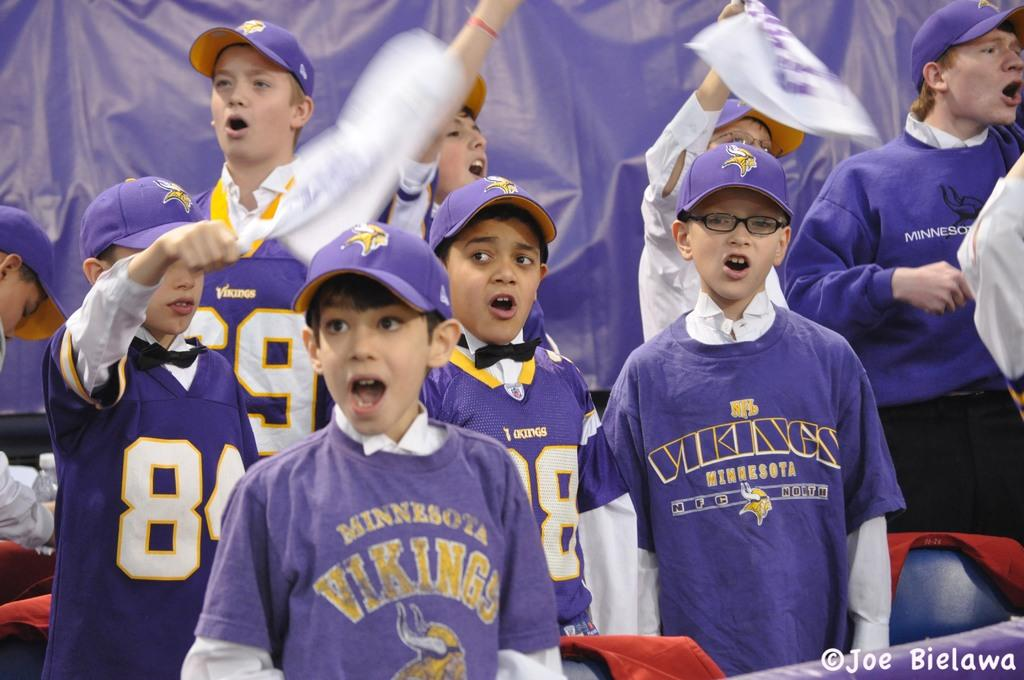<image>
Provide a brief description of the given image. Young Minnesota Vikings fans cheering at a game 